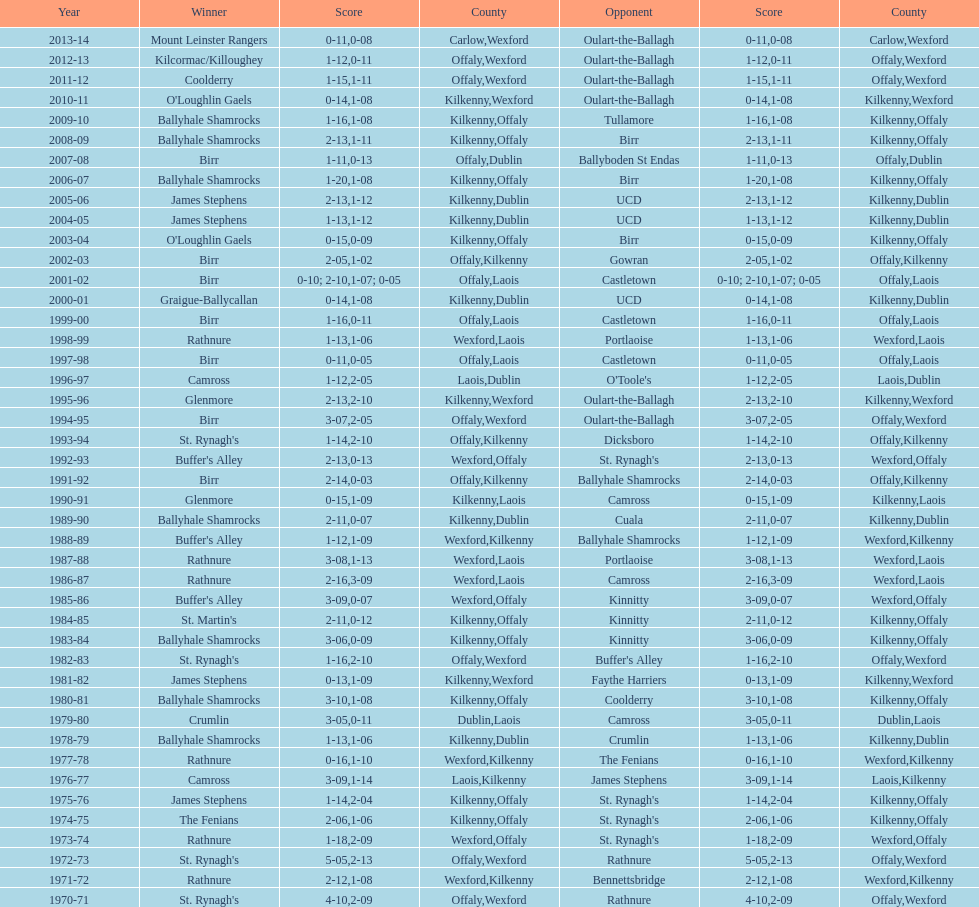Which champion is beside mount leinster rangers? Kilcormac/Killoughey. 